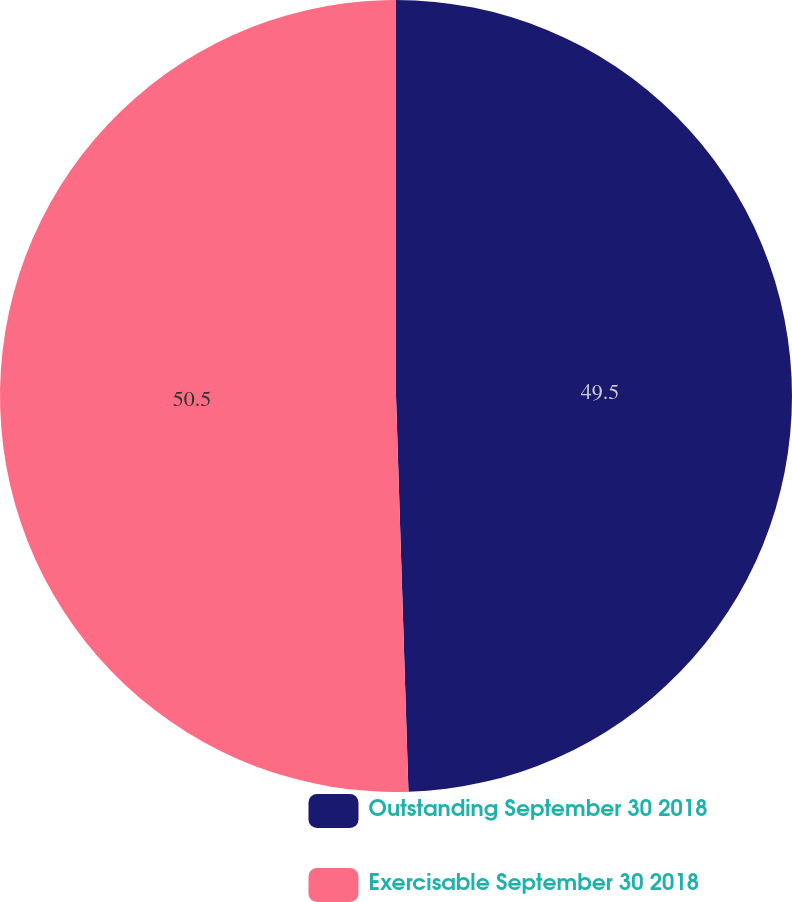<chart> <loc_0><loc_0><loc_500><loc_500><pie_chart><fcel>Outstanding September 30 2018<fcel>Exercisable September 30 2018<nl><fcel>49.5%<fcel>50.5%<nl></chart> 